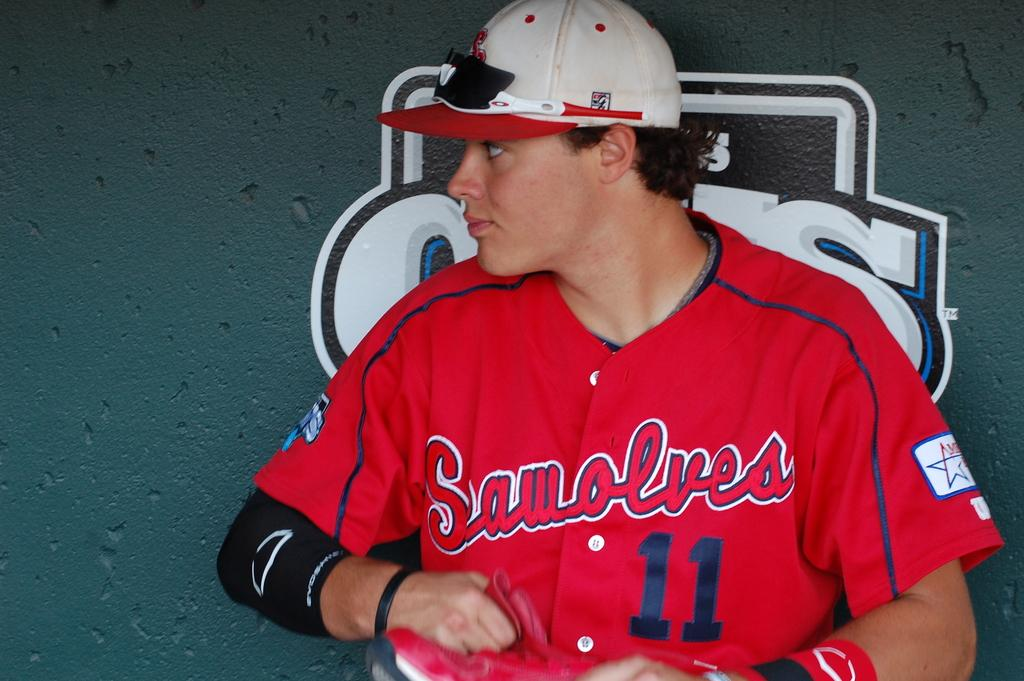<image>
Offer a succinct explanation of the picture presented. a person that has the number 11 on their jersey 